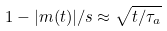Convert formula to latex. <formula><loc_0><loc_0><loc_500><loc_500>1 - | m ( t ) | / s \approx \sqrt { t / \tau _ { a } }</formula> 